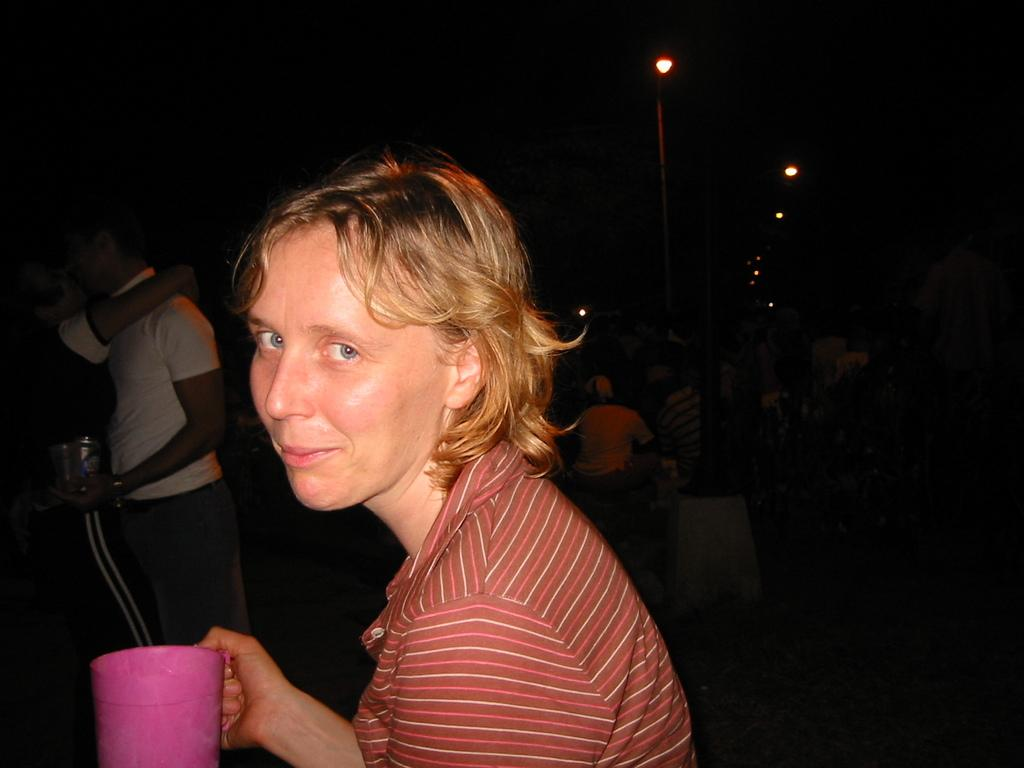Who is present in the image? There is a woman in the image. What is the woman doing in the image? The woman is smiling in the image. What is the woman holding in her right hand? The woman is holding a mug in her right hand. What type of clothing is the woman wearing? The woman is wearing a t-shirt. What can be seen on the right side of the image? There are lights on the right side of the image. What time is displayed on the clock in the image? There is no clock present in the image. What level of difficulty is the beetle game set to in the image? There is no beetle game present in the image. 